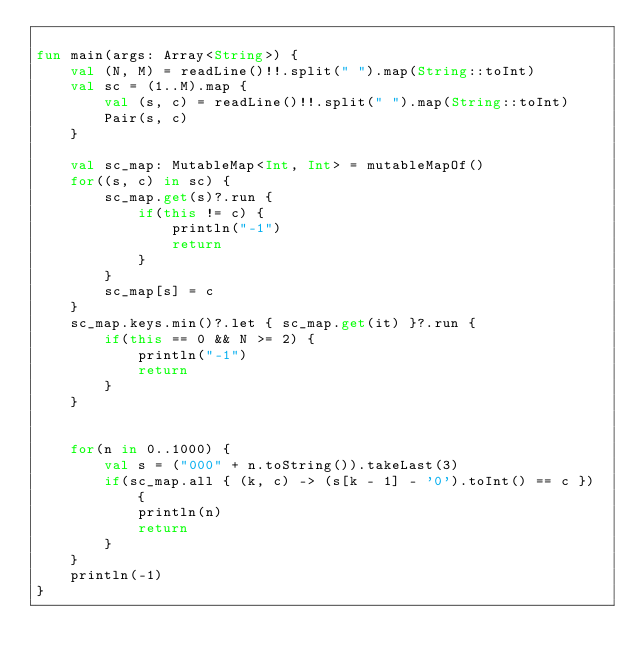Convert code to text. <code><loc_0><loc_0><loc_500><loc_500><_Kotlin_>
fun main(args: Array<String>) {
    val (N, M) = readLine()!!.split(" ").map(String::toInt)
    val sc = (1..M).map {
        val (s, c) = readLine()!!.split(" ").map(String::toInt)
        Pair(s, c)
    }

    val sc_map: MutableMap<Int, Int> = mutableMapOf()
    for((s, c) in sc) {
        sc_map.get(s)?.run {
            if(this != c) {
                println("-1")
                return
            }
        }
        sc_map[s] = c
    }
    sc_map.keys.min()?.let { sc_map.get(it) }?.run {
        if(this == 0 && N >= 2) {
            println("-1")
            return
        }
    }


    for(n in 0..1000) {
        val s = ("000" + n.toString()).takeLast(3)
        if(sc_map.all { (k, c) -> (s[k - 1] - '0').toInt() == c }) {
            println(n)
            return
        }
    }
    println(-1)
}</code> 